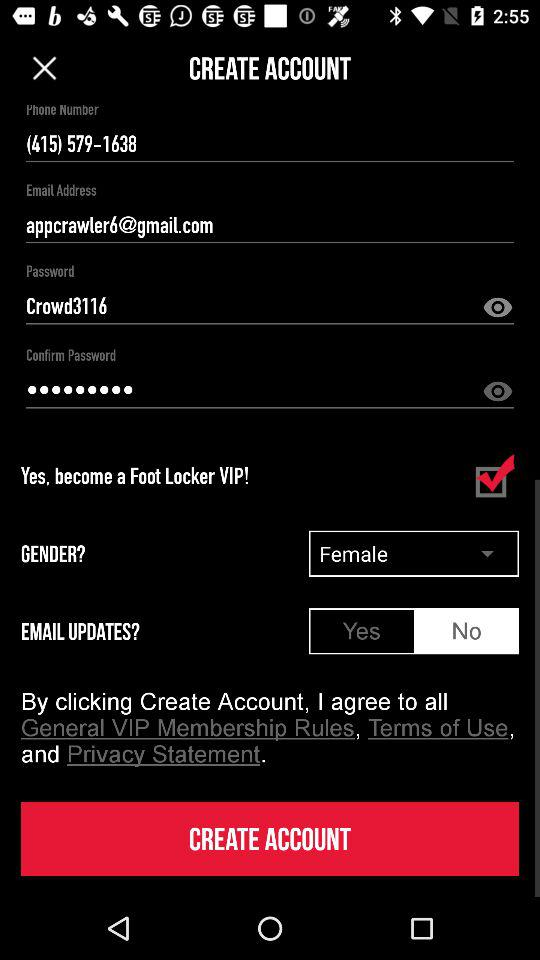What is the status of "EMAIL UPDATES"? The status is "No". 